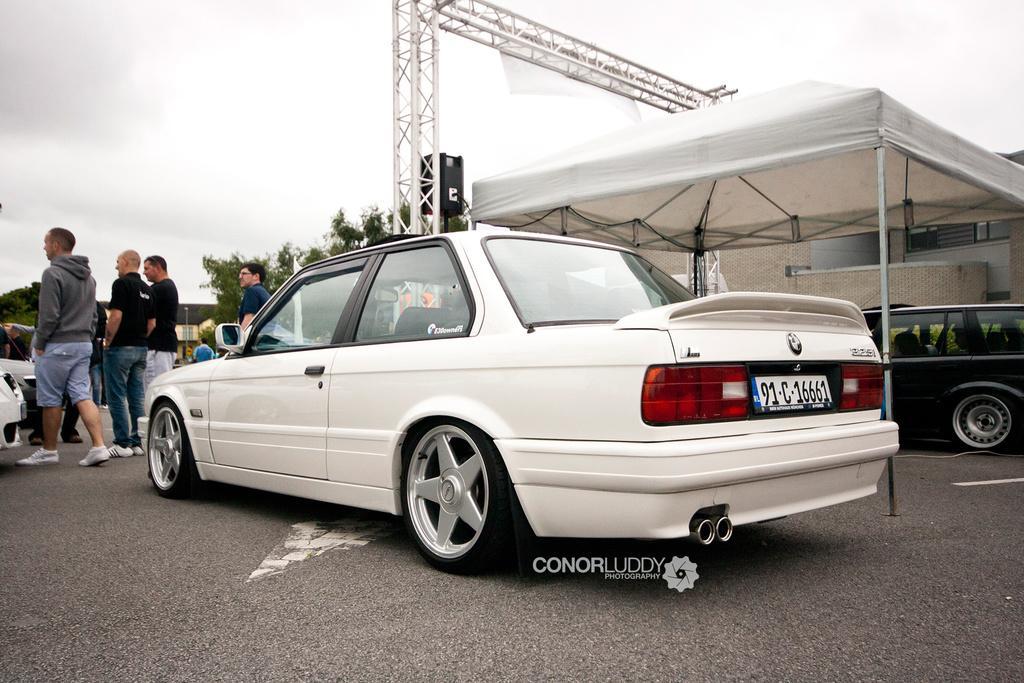Can you describe this image briefly? In this image we can see some vehicles parked on the ground. On the left side of the image we can see a group of people standing on the ground. In the center of the image we can see a speaker on stand, metal frame and group of trees. On the right side of the image we can see a tent with poles and a building. At the top of the image we can see the sky. 